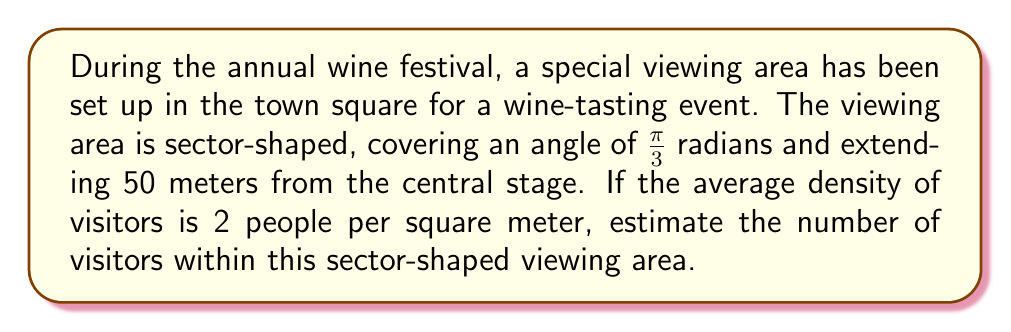Could you help me with this problem? To solve this problem, we need to follow these steps:

1) First, we need to calculate the area of the sector. The formula for the area of a sector is:

   $$A = \frac{1}{2}r^2\theta$$

   Where $r$ is the radius and $\theta$ is the angle in radians.

2) We are given:
   $r = 50$ meters
   $\theta = \frac{\pi}{3}$ radians

3) Let's substitute these values into the formula:

   $$A = \frac{1}{2}(50)^2(\frac{\pi}{3})$$

4) Simplify:
   
   $$A = \frac{1}{2}(2500)(\frac{\pi}{3}) = 1250(\frac{\pi}{3})$$

5) Calculate:
   
   $$A \approx 1308.997$$ square meters

6) Now that we have the area, we can calculate the number of visitors. We're given that the average density is 2 people per square meter.

7) To find the number of visitors, we multiply the area by the density:

   $$\text{Number of visitors} = 1308.997 \times 2 \approx 2617.994$$

8) Since we can't have a fractional person, we round to the nearest whole number.
Answer: Approximately 2618 visitors 